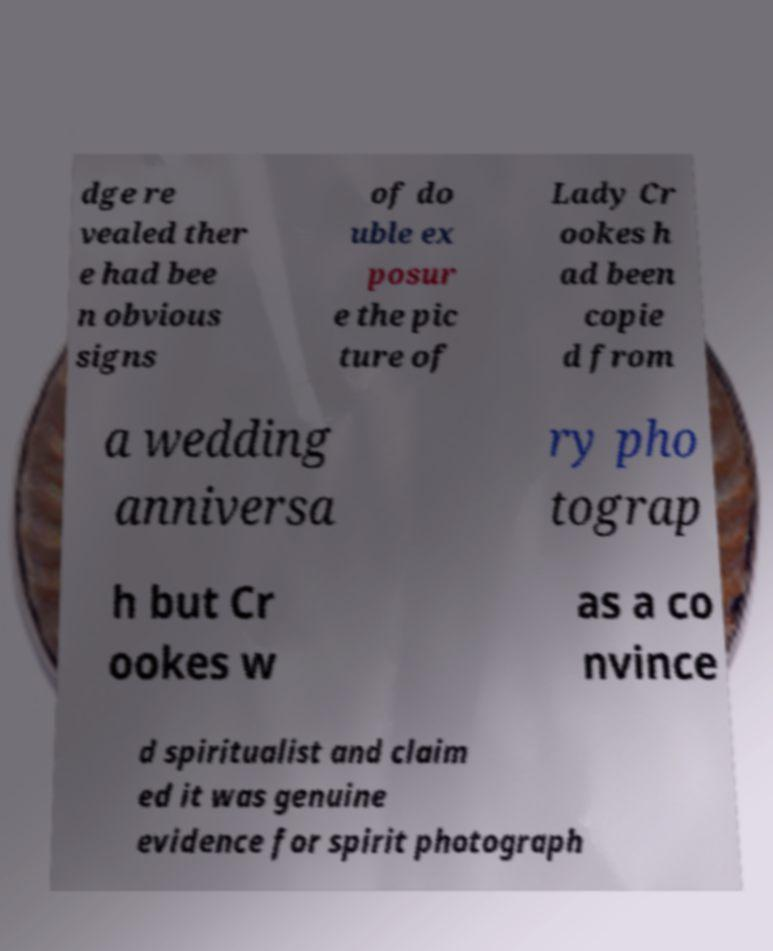I need the written content from this picture converted into text. Can you do that? dge re vealed ther e had bee n obvious signs of do uble ex posur e the pic ture of Lady Cr ookes h ad been copie d from a wedding anniversa ry pho tograp h but Cr ookes w as a co nvince d spiritualist and claim ed it was genuine evidence for spirit photograph 